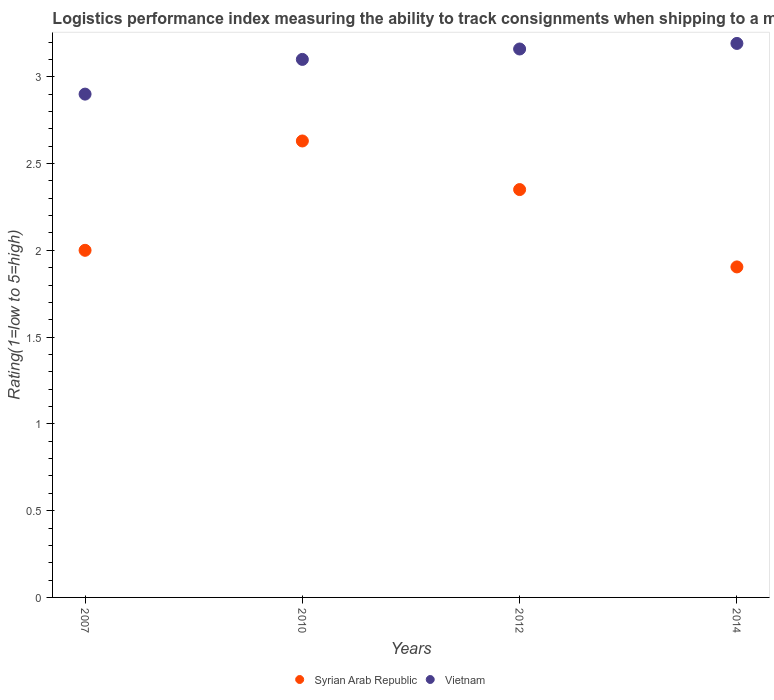How many different coloured dotlines are there?
Offer a very short reply. 2. Is the number of dotlines equal to the number of legend labels?
Make the answer very short. Yes. What is the Logistic performance index in Syrian Arab Republic in 2014?
Offer a terse response. 1.9. Across all years, what is the maximum Logistic performance index in Vietnam?
Offer a terse response. 3.19. Across all years, what is the minimum Logistic performance index in Vietnam?
Provide a succinct answer. 2.9. In which year was the Logistic performance index in Syrian Arab Republic maximum?
Your response must be concise. 2010. In which year was the Logistic performance index in Syrian Arab Republic minimum?
Ensure brevity in your answer.  2014. What is the total Logistic performance index in Syrian Arab Republic in the graph?
Give a very brief answer. 8.88. What is the difference between the Logistic performance index in Vietnam in 2007 and that in 2014?
Offer a very short reply. -0.29. What is the difference between the Logistic performance index in Syrian Arab Republic in 2012 and the Logistic performance index in Vietnam in 2007?
Keep it short and to the point. -0.55. What is the average Logistic performance index in Syrian Arab Republic per year?
Your response must be concise. 2.22. In the year 2010, what is the difference between the Logistic performance index in Vietnam and Logistic performance index in Syrian Arab Republic?
Make the answer very short. 0.47. In how many years, is the Logistic performance index in Vietnam greater than 2.3?
Provide a short and direct response. 4. What is the ratio of the Logistic performance index in Vietnam in 2007 to that in 2014?
Your answer should be compact. 0.91. Is the Logistic performance index in Vietnam in 2007 less than that in 2014?
Your answer should be very brief. Yes. What is the difference between the highest and the second highest Logistic performance index in Vietnam?
Offer a terse response. 0.03. What is the difference between the highest and the lowest Logistic performance index in Vietnam?
Make the answer very short. 0.29. In how many years, is the Logistic performance index in Vietnam greater than the average Logistic performance index in Vietnam taken over all years?
Provide a short and direct response. 3. Is the sum of the Logistic performance index in Syrian Arab Republic in 2007 and 2012 greater than the maximum Logistic performance index in Vietnam across all years?
Your answer should be very brief. Yes. Does the Logistic performance index in Syrian Arab Republic monotonically increase over the years?
Your answer should be very brief. No. Is the Logistic performance index in Vietnam strictly greater than the Logistic performance index in Syrian Arab Republic over the years?
Your answer should be compact. Yes. How many dotlines are there?
Your response must be concise. 2. How many years are there in the graph?
Ensure brevity in your answer.  4. What is the difference between two consecutive major ticks on the Y-axis?
Give a very brief answer. 0.5. Does the graph contain grids?
Provide a succinct answer. No. How are the legend labels stacked?
Your response must be concise. Horizontal. What is the title of the graph?
Your answer should be compact. Logistics performance index measuring the ability to track consignments when shipping to a market. Does "India" appear as one of the legend labels in the graph?
Ensure brevity in your answer.  No. What is the label or title of the Y-axis?
Provide a short and direct response. Rating(1=low to 5=high). What is the Rating(1=low to 5=high) of Vietnam in 2007?
Offer a terse response. 2.9. What is the Rating(1=low to 5=high) in Syrian Arab Republic in 2010?
Give a very brief answer. 2.63. What is the Rating(1=low to 5=high) of Syrian Arab Republic in 2012?
Make the answer very short. 2.35. What is the Rating(1=low to 5=high) in Vietnam in 2012?
Offer a very short reply. 3.16. What is the Rating(1=low to 5=high) of Syrian Arab Republic in 2014?
Your answer should be compact. 1.9. What is the Rating(1=low to 5=high) of Vietnam in 2014?
Your answer should be compact. 3.19. Across all years, what is the maximum Rating(1=low to 5=high) in Syrian Arab Republic?
Your answer should be compact. 2.63. Across all years, what is the maximum Rating(1=low to 5=high) of Vietnam?
Provide a short and direct response. 3.19. Across all years, what is the minimum Rating(1=low to 5=high) in Syrian Arab Republic?
Your answer should be very brief. 1.9. Across all years, what is the minimum Rating(1=low to 5=high) in Vietnam?
Offer a terse response. 2.9. What is the total Rating(1=low to 5=high) in Syrian Arab Republic in the graph?
Keep it short and to the point. 8.88. What is the total Rating(1=low to 5=high) of Vietnam in the graph?
Make the answer very short. 12.35. What is the difference between the Rating(1=low to 5=high) of Syrian Arab Republic in 2007 and that in 2010?
Your answer should be compact. -0.63. What is the difference between the Rating(1=low to 5=high) of Vietnam in 2007 and that in 2010?
Your response must be concise. -0.2. What is the difference between the Rating(1=low to 5=high) of Syrian Arab Republic in 2007 and that in 2012?
Provide a short and direct response. -0.35. What is the difference between the Rating(1=low to 5=high) of Vietnam in 2007 and that in 2012?
Make the answer very short. -0.26. What is the difference between the Rating(1=low to 5=high) in Syrian Arab Republic in 2007 and that in 2014?
Your response must be concise. 0.1. What is the difference between the Rating(1=low to 5=high) of Vietnam in 2007 and that in 2014?
Your response must be concise. -0.29. What is the difference between the Rating(1=low to 5=high) of Syrian Arab Republic in 2010 and that in 2012?
Offer a terse response. 0.28. What is the difference between the Rating(1=low to 5=high) in Vietnam in 2010 and that in 2012?
Provide a succinct answer. -0.06. What is the difference between the Rating(1=low to 5=high) in Syrian Arab Republic in 2010 and that in 2014?
Your answer should be compact. 0.73. What is the difference between the Rating(1=low to 5=high) in Vietnam in 2010 and that in 2014?
Your answer should be compact. -0.09. What is the difference between the Rating(1=low to 5=high) of Syrian Arab Republic in 2012 and that in 2014?
Keep it short and to the point. 0.45. What is the difference between the Rating(1=low to 5=high) of Vietnam in 2012 and that in 2014?
Offer a very short reply. -0.03. What is the difference between the Rating(1=low to 5=high) in Syrian Arab Republic in 2007 and the Rating(1=low to 5=high) in Vietnam in 2010?
Your answer should be very brief. -1.1. What is the difference between the Rating(1=low to 5=high) in Syrian Arab Republic in 2007 and the Rating(1=low to 5=high) in Vietnam in 2012?
Provide a short and direct response. -1.16. What is the difference between the Rating(1=low to 5=high) of Syrian Arab Republic in 2007 and the Rating(1=low to 5=high) of Vietnam in 2014?
Your answer should be very brief. -1.19. What is the difference between the Rating(1=low to 5=high) in Syrian Arab Republic in 2010 and the Rating(1=low to 5=high) in Vietnam in 2012?
Offer a very short reply. -0.53. What is the difference between the Rating(1=low to 5=high) of Syrian Arab Republic in 2010 and the Rating(1=low to 5=high) of Vietnam in 2014?
Offer a terse response. -0.56. What is the difference between the Rating(1=low to 5=high) of Syrian Arab Republic in 2012 and the Rating(1=low to 5=high) of Vietnam in 2014?
Keep it short and to the point. -0.84. What is the average Rating(1=low to 5=high) of Syrian Arab Republic per year?
Give a very brief answer. 2.22. What is the average Rating(1=low to 5=high) in Vietnam per year?
Provide a short and direct response. 3.09. In the year 2010, what is the difference between the Rating(1=low to 5=high) of Syrian Arab Republic and Rating(1=low to 5=high) of Vietnam?
Ensure brevity in your answer.  -0.47. In the year 2012, what is the difference between the Rating(1=low to 5=high) in Syrian Arab Republic and Rating(1=low to 5=high) in Vietnam?
Your answer should be very brief. -0.81. In the year 2014, what is the difference between the Rating(1=low to 5=high) of Syrian Arab Republic and Rating(1=low to 5=high) of Vietnam?
Provide a succinct answer. -1.29. What is the ratio of the Rating(1=low to 5=high) of Syrian Arab Republic in 2007 to that in 2010?
Give a very brief answer. 0.76. What is the ratio of the Rating(1=low to 5=high) of Vietnam in 2007 to that in 2010?
Offer a terse response. 0.94. What is the ratio of the Rating(1=low to 5=high) of Syrian Arab Republic in 2007 to that in 2012?
Ensure brevity in your answer.  0.85. What is the ratio of the Rating(1=low to 5=high) of Vietnam in 2007 to that in 2012?
Your answer should be compact. 0.92. What is the ratio of the Rating(1=low to 5=high) in Syrian Arab Republic in 2007 to that in 2014?
Give a very brief answer. 1.05. What is the ratio of the Rating(1=low to 5=high) of Vietnam in 2007 to that in 2014?
Keep it short and to the point. 0.91. What is the ratio of the Rating(1=low to 5=high) of Syrian Arab Republic in 2010 to that in 2012?
Make the answer very short. 1.12. What is the ratio of the Rating(1=low to 5=high) in Syrian Arab Republic in 2010 to that in 2014?
Your answer should be compact. 1.38. What is the ratio of the Rating(1=low to 5=high) in Vietnam in 2010 to that in 2014?
Provide a succinct answer. 0.97. What is the ratio of the Rating(1=low to 5=high) of Syrian Arab Republic in 2012 to that in 2014?
Give a very brief answer. 1.23. What is the difference between the highest and the second highest Rating(1=low to 5=high) of Syrian Arab Republic?
Keep it short and to the point. 0.28. What is the difference between the highest and the second highest Rating(1=low to 5=high) of Vietnam?
Offer a terse response. 0.03. What is the difference between the highest and the lowest Rating(1=low to 5=high) of Syrian Arab Republic?
Provide a short and direct response. 0.73. What is the difference between the highest and the lowest Rating(1=low to 5=high) of Vietnam?
Your answer should be very brief. 0.29. 